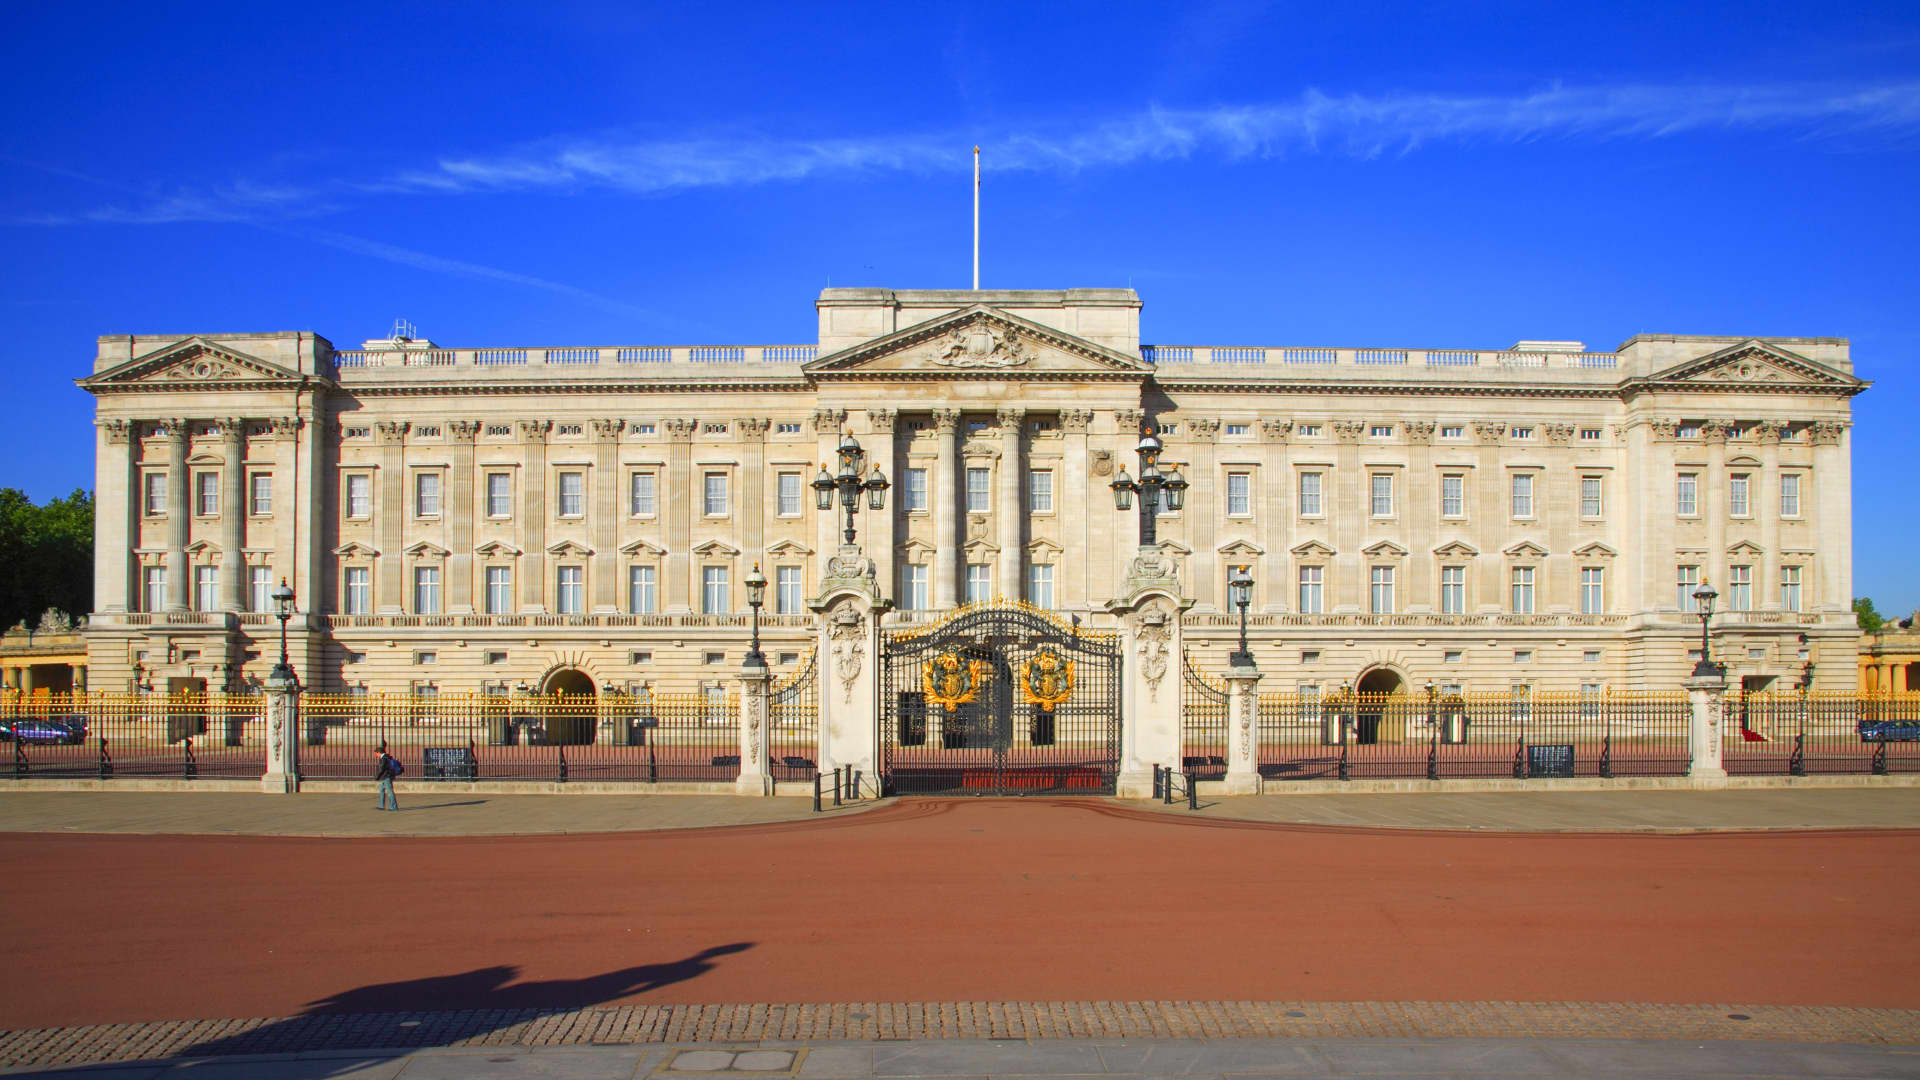Imagine Buckingham Palace was built on a different planet. What would it look like and how would it function? If Buckingham Palace were built on a different planet, let's imagine it on a breathtaking, lush green planet with towering crystal mountains and floating islands. The palace’s architecture would blend with the alien environment, featuring radiant crystalline structures and bioluminescent accents. Instead of traditional stone, the walls would be constructed from translucent, shimmering materials that change color with the planetary cycles. The gardens would be populated with exotic, glowing flora and fauna unique to the planet, creating a surreal and magical landscape. Functionally, the palace would serve not only as the residence of an intergalactic monarch but also as a hub for interplanetary diplomacy, with advanced technology integrating seamlessly with the natural environment to ensure sustainable living and communication across the cosmos. 